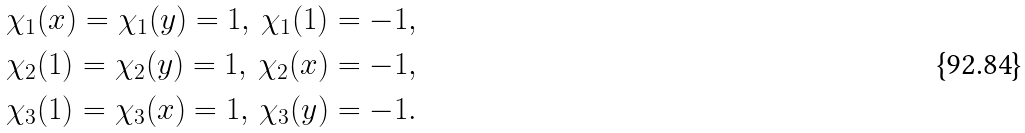<formula> <loc_0><loc_0><loc_500><loc_500>& \chi _ { 1 } ( x ) = \chi _ { 1 } ( y ) = 1 , \, \chi _ { 1 } ( 1 ) = - 1 , \\ & \chi _ { 2 } ( 1 ) = \chi _ { 2 } ( y ) = 1 , \, \chi _ { 2 } ( x ) = - 1 , \\ & \chi _ { 3 } ( 1 ) = \chi _ { 3 } ( x ) = 1 , \, \chi _ { 3 } ( y ) = - 1 .</formula> 